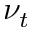<formula> <loc_0><loc_0><loc_500><loc_500>\nu _ { t }</formula> 